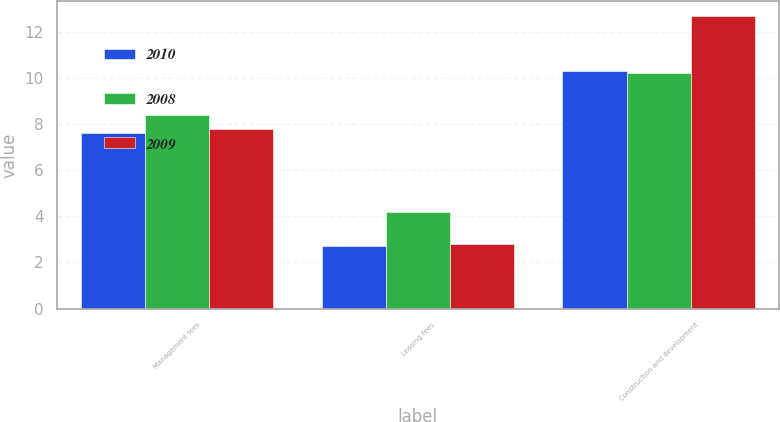Convert chart. <chart><loc_0><loc_0><loc_500><loc_500><stacked_bar_chart><ecel><fcel>Management fees<fcel>Leasing fees<fcel>Construction and development<nl><fcel>2010<fcel>7.6<fcel>2.7<fcel>10.3<nl><fcel>2008<fcel>8.4<fcel>4.2<fcel>10.2<nl><fcel>2009<fcel>7.8<fcel>2.8<fcel>12.7<nl></chart> 